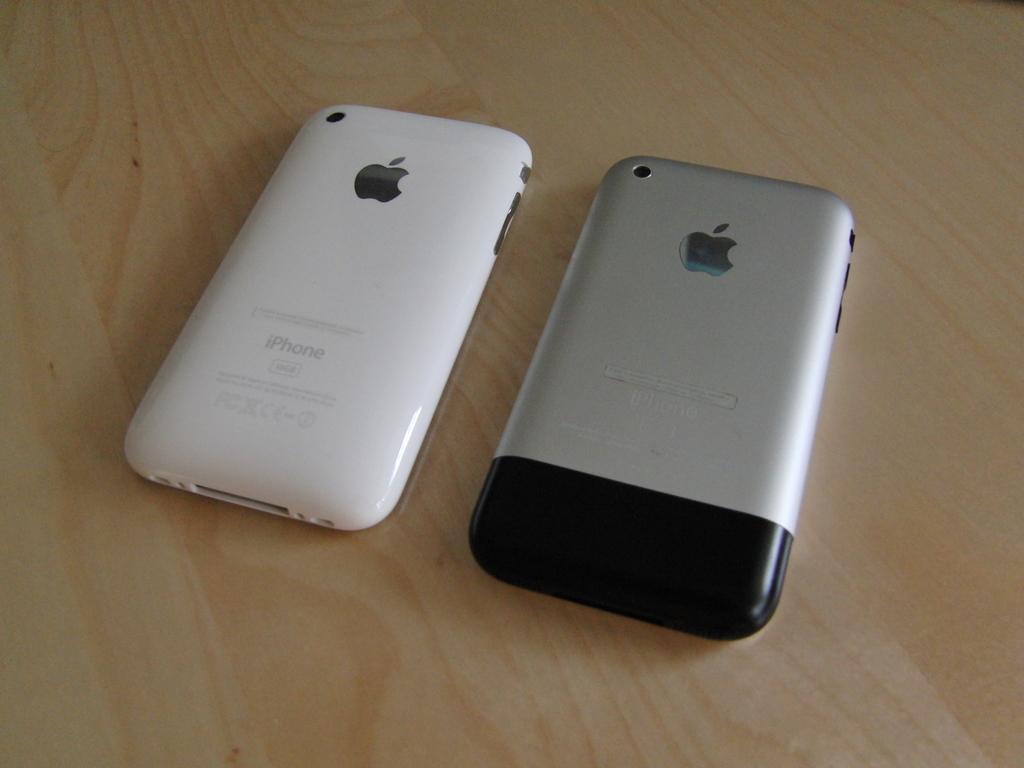What brand of phone is this?
Make the answer very short. Iphone. What type of iphone are these?
Ensure brevity in your answer.  Unanswerable. 